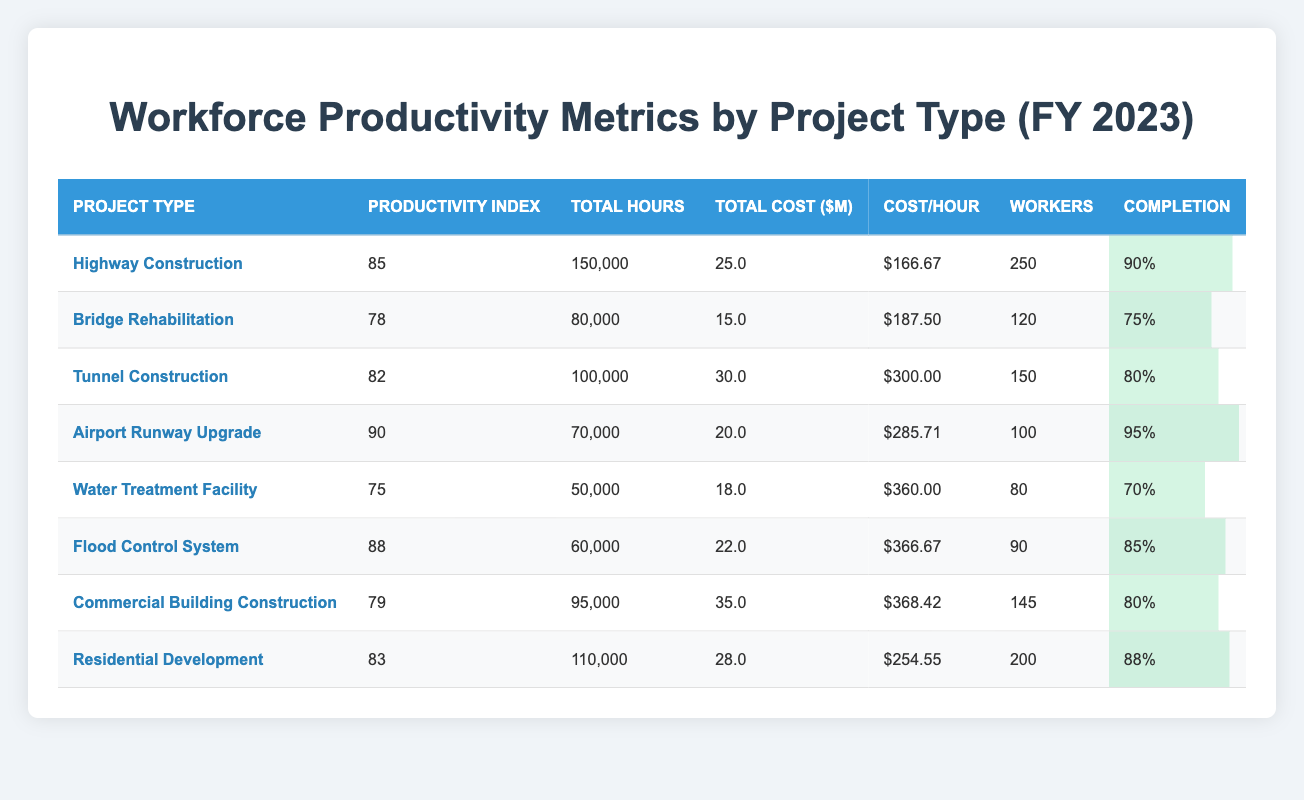What is the total project cost of the Tunnel Construction project? The table shows that the total project cost for Tunnel Construction is listed as $30,000,000.
Answer: $30,000,000 Which project type has the highest average productivity index? The table indicates that the Airport Runway Upgrade has the highest average productivity index at 90.
Answer: Airport Runway Upgrade What is the average cost per hour for all projects? To calculate this, sum the cost per hour for all projects: (166.67 + 187.50 + 300.00 + 285.71 + 360.00 + 366.67 + 368.42 + 254.55) = 2,085.00. There are 8 projects, so the average cost per hour is 2,085.00 / 8 = 260.63.
Answer: $260.63 Is the completion percentage for the Flood Control System greater than 80%? The completion percentage for Flood Control System is 85%, which is greater than 80%. Hence, the answer is yes.
Answer: Yes How many workers are involved in the Water Treatment Facility project? According to the table, the Water Treatment Facility has 80 workers assigned to it.
Answer: 80 What is the total number of hours worked across all projects? The total hours worked can be calculated by summing the hours for all projects: (150,000 + 80,000 + 100,000 + 70,000 + 50,000 + 60,000 + 95,000 + 110,000) = 715,000 hours.
Answer: 715,000 Which project type has the lowest completion percentage and what is it? Reviewing the table, the Water Treatment Facility has the lowest completion percentage at 70%.
Answer: Water Treatment Facility, 70% If we consider only projects with a completion percentage of 85% or higher, how many total hours were worked on these projects? The projects with completion percentages of 85% or higher are: Highway Construction (150,000 hours), Airport Runway Upgrade (70,000 hours), and Flood Control System (60,000 hours). Total hours worked is 150,000 + 70,000 + 60,000 = 280,000 hours.
Answer: 280,000 What is the cost per hour for the Bridge Rehabilitation project, and how does it compare to the average cost per hour? The cost per hour for Bridge Rehabilitation is $187.50. The average cost per hour is $260.63. Comparing these, $187.50 is lower than the average.
Answer: $187.50, lower than average Which project requires the highest cost per hour, and what is that cost? The table shows that the Water Treatment Facility requires the highest cost per hour at $360.00.
Answer: $360.00 What percentage of the total hours worked is attributed to the Residential Development project? The total hours worked across all projects is 715,000 hours, and the Residential Development project has 110,000 hours. The percentage is (110,000 / 715,000) * 100 = 15.38%.
Answer: 15.38% 